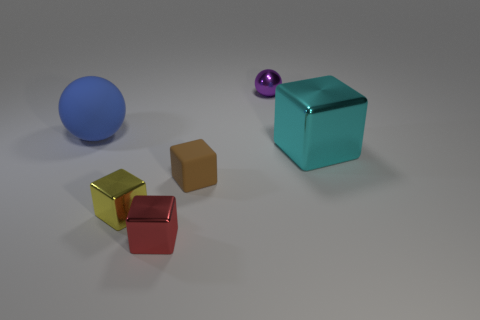Is the shape of the metallic thing behind the big cyan shiny thing the same as the tiny red shiny object? No, the shape of the metallic object behind the large cyan box is spherical, whereas the tiny red object in front appears to be cubic, which means they do not share the same shape. 